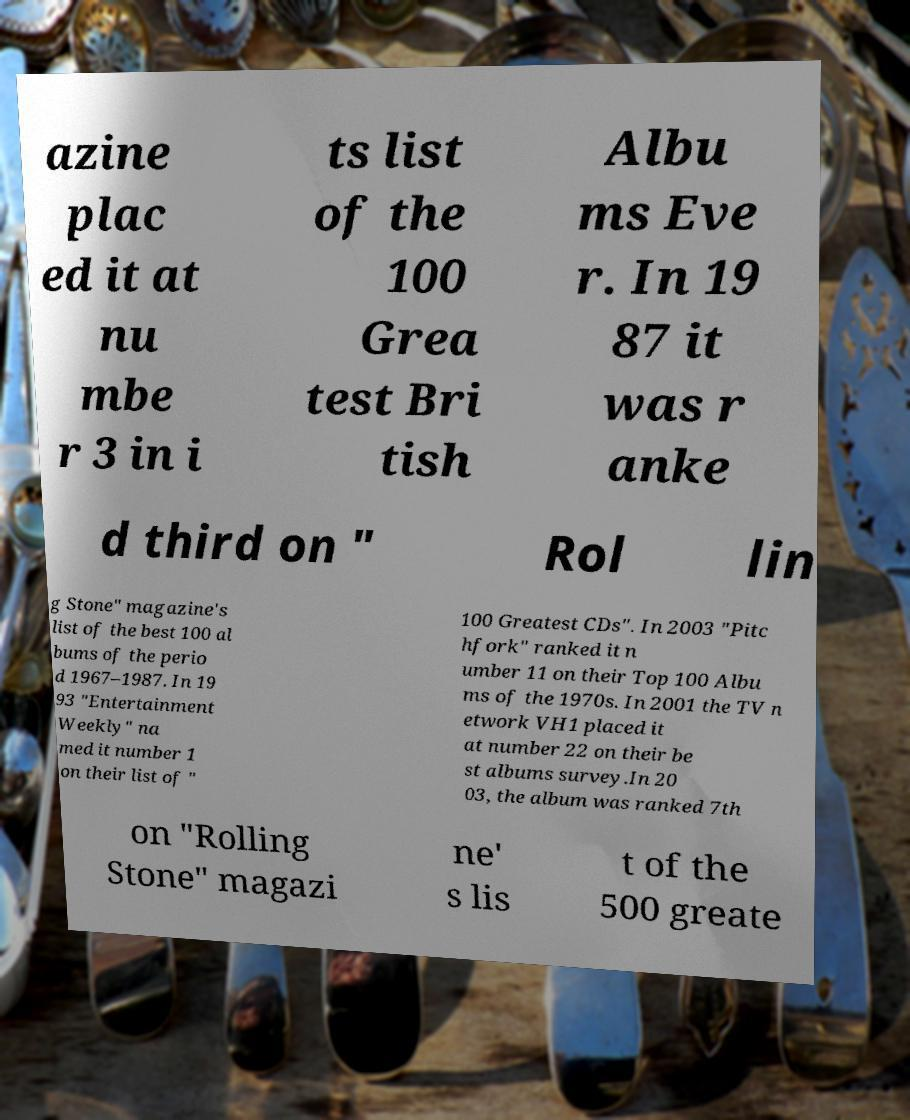Can you read and provide the text displayed in the image?This photo seems to have some interesting text. Can you extract and type it out for me? azine plac ed it at nu mbe r 3 in i ts list of the 100 Grea test Bri tish Albu ms Eve r. In 19 87 it was r anke d third on " Rol lin g Stone" magazine's list of the best 100 al bums of the perio d 1967–1987. In 19 93 "Entertainment Weekly" na med it number 1 on their list of " 100 Greatest CDs". In 2003 "Pitc hfork" ranked it n umber 11 on their Top 100 Albu ms of the 1970s. In 2001 the TV n etwork VH1 placed it at number 22 on their be st albums survey.In 20 03, the album was ranked 7th on "Rolling Stone" magazi ne' s lis t of the 500 greate 